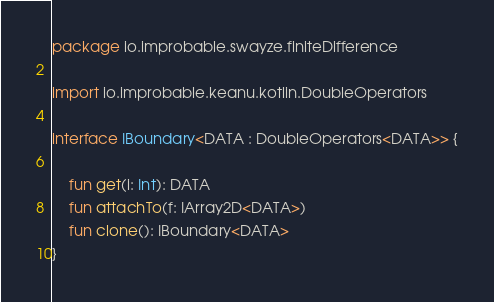<code> <loc_0><loc_0><loc_500><loc_500><_Kotlin_>package io.improbable.swayze.finiteDifference

import io.improbable.keanu.kotlin.DoubleOperators

interface IBoundary<DATA : DoubleOperators<DATA>> {

    fun get(i: Int): DATA
    fun attachTo(f: IArray2D<DATA>)
    fun clone(): IBoundary<DATA>
}</code> 